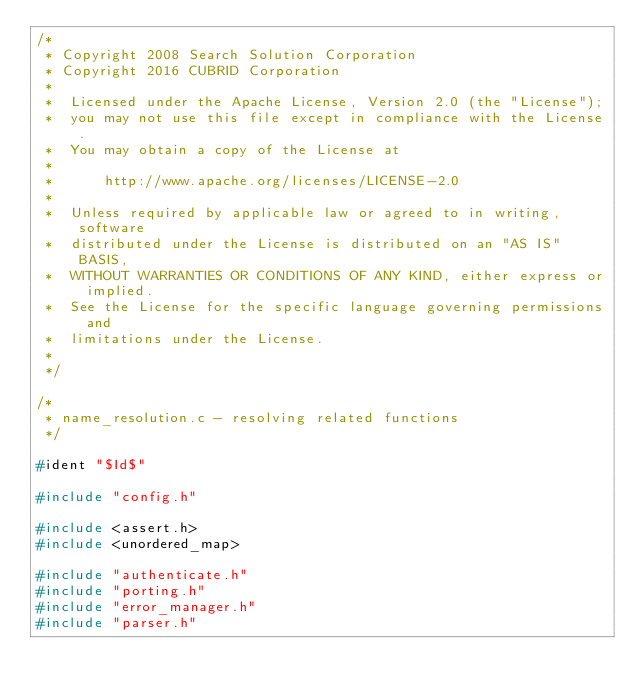Convert code to text. <code><loc_0><loc_0><loc_500><loc_500><_C_>/*
 * Copyright 2008 Search Solution Corporation
 * Copyright 2016 CUBRID Corporation
 *
 *  Licensed under the Apache License, Version 2.0 (the "License");
 *  you may not use this file except in compliance with the License.
 *  You may obtain a copy of the License at
 *
 *      http://www.apache.org/licenses/LICENSE-2.0
 *
 *  Unless required by applicable law or agreed to in writing, software
 *  distributed under the License is distributed on an "AS IS" BASIS,
 *  WITHOUT WARRANTIES OR CONDITIONS OF ANY KIND, either express or implied.
 *  See the License for the specific language governing permissions and
 *  limitations under the License.
 *
 */

/*
 * name_resolution.c - resolving related functions
 */

#ident "$Id$"

#include "config.h"

#include <assert.h>
#include <unordered_map>

#include "authenticate.h"
#include "porting.h"
#include "error_manager.h"
#include "parser.h"</code> 